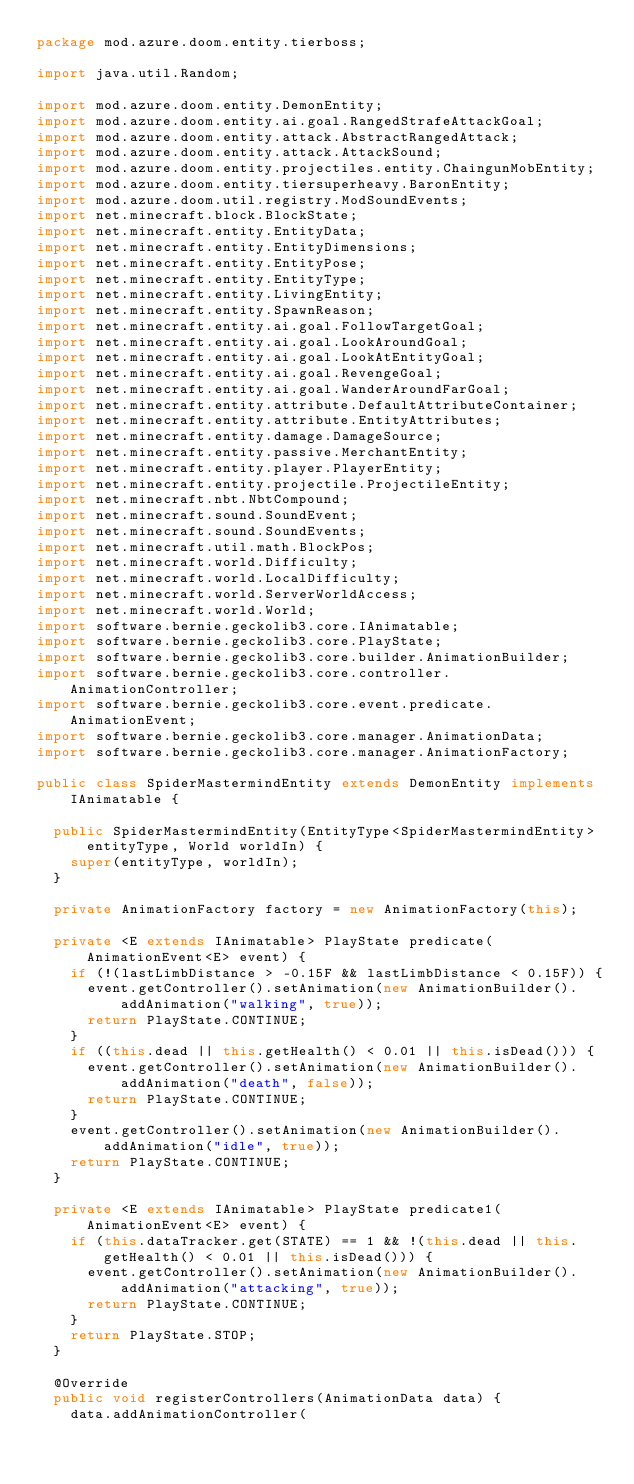<code> <loc_0><loc_0><loc_500><loc_500><_Java_>package mod.azure.doom.entity.tierboss;

import java.util.Random;

import mod.azure.doom.entity.DemonEntity;
import mod.azure.doom.entity.ai.goal.RangedStrafeAttackGoal;
import mod.azure.doom.entity.attack.AbstractRangedAttack;
import mod.azure.doom.entity.attack.AttackSound;
import mod.azure.doom.entity.projectiles.entity.ChaingunMobEntity;
import mod.azure.doom.entity.tiersuperheavy.BaronEntity;
import mod.azure.doom.util.registry.ModSoundEvents;
import net.minecraft.block.BlockState;
import net.minecraft.entity.EntityData;
import net.minecraft.entity.EntityDimensions;
import net.minecraft.entity.EntityPose;
import net.minecraft.entity.EntityType;
import net.minecraft.entity.LivingEntity;
import net.minecraft.entity.SpawnReason;
import net.minecraft.entity.ai.goal.FollowTargetGoal;
import net.minecraft.entity.ai.goal.LookAroundGoal;
import net.minecraft.entity.ai.goal.LookAtEntityGoal;
import net.minecraft.entity.ai.goal.RevengeGoal;
import net.minecraft.entity.ai.goal.WanderAroundFarGoal;
import net.minecraft.entity.attribute.DefaultAttributeContainer;
import net.minecraft.entity.attribute.EntityAttributes;
import net.minecraft.entity.damage.DamageSource;
import net.minecraft.entity.passive.MerchantEntity;
import net.minecraft.entity.player.PlayerEntity;
import net.minecraft.entity.projectile.ProjectileEntity;
import net.minecraft.nbt.NbtCompound;
import net.minecraft.sound.SoundEvent;
import net.minecraft.sound.SoundEvents;
import net.minecraft.util.math.BlockPos;
import net.minecraft.world.Difficulty;
import net.minecraft.world.LocalDifficulty;
import net.minecraft.world.ServerWorldAccess;
import net.minecraft.world.World;
import software.bernie.geckolib3.core.IAnimatable;
import software.bernie.geckolib3.core.PlayState;
import software.bernie.geckolib3.core.builder.AnimationBuilder;
import software.bernie.geckolib3.core.controller.AnimationController;
import software.bernie.geckolib3.core.event.predicate.AnimationEvent;
import software.bernie.geckolib3.core.manager.AnimationData;
import software.bernie.geckolib3.core.manager.AnimationFactory;

public class SpiderMastermindEntity extends DemonEntity implements IAnimatable {

	public SpiderMastermindEntity(EntityType<SpiderMastermindEntity> entityType, World worldIn) {
		super(entityType, worldIn);
	}

	private AnimationFactory factory = new AnimationFactory(this);

	private <E extends IAnimatable> PlayState predicate(AnimationEvent<E> event) {
		if (!(lastLimbDistance > -0.15F && lastLimbDistance < 0.15F)) {
			event.getController().setAnimation(new AnimationBuilder().addAnimation("walking", true));
			return PlayState.CONTINUE;
		}
		if ((this.dead || this.getHealth() < 0.01 || this.isDead())) {
			event.getController().setAnimation(new AnimationBuilder().addAnimation("death", false));
			return PlayState.CONTINUE;
		}
		event.getController().setAnimation(new AnimationBuilder().addAnimation("idle", true));
		return PlayState.CONTINUE;
	}

	private <E extends IAnimatable> PlayState predicate1(AnimationEvent<E> event) {
		if (this.dataTracker.get(STATE) == 1 && !(this.dead || this.getHealth() < 0.01 || this.isDead())) {
			event.getController().setAnimation(new AnimationBuilder().addAnimation("attacking", true));
			return PlayState.CONTINUE;
		}
		return PlayState.STOP;
	}

	@Override
	public void registerControllers(AnimationData data) {
		data.addAnimationController(</code> 